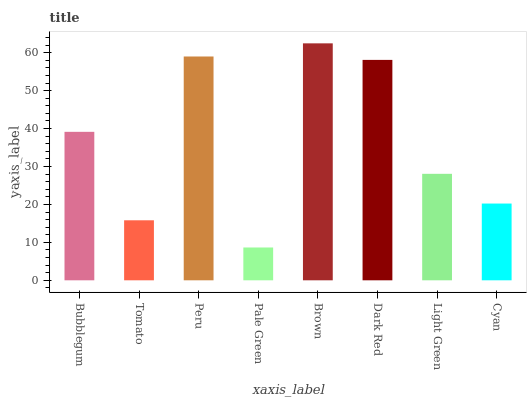Is Tomato the minimum?
Answer yes or no. No. Is Tomato the maximum?
Answer yes or no. No. Is Bubblegum greater than Tomato?
Answer yes or no. Yes. Is Tomato less than Bubblegum?
Answer yes or no. Yes. Is Tomato greater than Bubblegum?
Answer yes or no. No. Is Bubblegum less than Tomato?
Answer yes or no. No. Is Bubblegum the high median?
Answer yes or no. Yes. Is Light Green the low median?
Answer yes or no. Yes. Is Peru the high median?
Answer yes or no. No. Is Peru the low median?
Answer yes or no. No. 